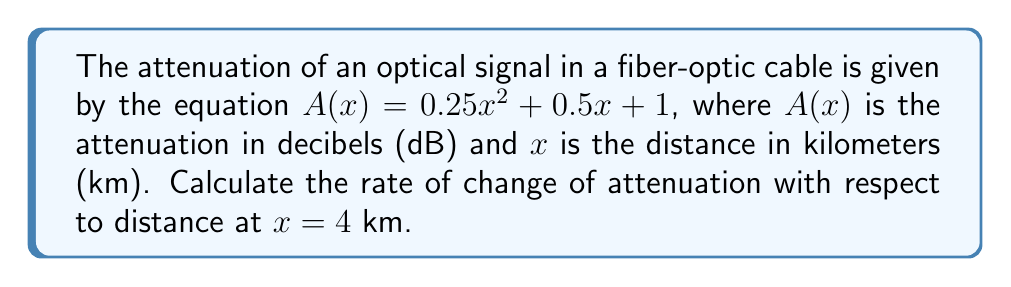Teach me how to tackle this problem. To find the rate of change of attenuation with respect to distance, we need to calculate the derivative of the attenuation function $A(x)$ and evaluate it at $x = 4$ km.

1. Given attenuation function: $A(x) = 0.25x^2 + 0.5x + 1$

2. Calculate the derivative $A'(x)$ using the power rule and constant rule:
   $$A'(x) = \frac{d}{dx}(0.25x^2 + 0.5x + 1)$$
   $$A'(x) = 0.25 \cdot 2x + 0.5 + 0$$
   $$A'(x) = 0.5x + 0.5$$

3. Evaluate $A'(x)$ at $x = 4$ km:
   $$A'(4) = 0.5(4) + 0.5$$
   $$A'(4) = 2 + 0.5 = 2.5$$

The rate of change of attenuation with respect to distance at $x = 4$ km is 2.5 dB/km.
Answer: $2.5$ dB/km 